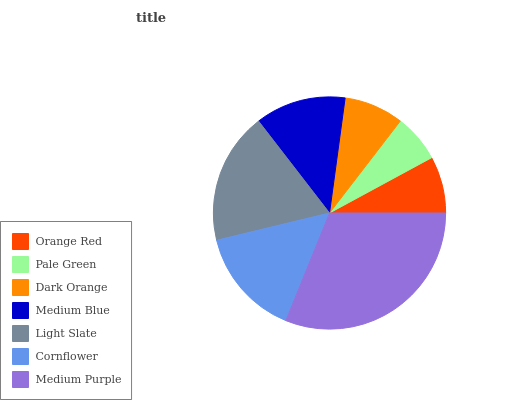Is Pale Green the minimum?
Answer yes or no. Yes. Is Medium Purple the maximum?
Answer yes or no. Yes. Is Dark Orange the minimum?
Answer yes or no. No. Is Dark Orange the maximum?
Answer yes or no. No. Is Dark Orange greater than Pale Green?
Answer yes or no. Yes. Is Pale Green less than Dark Orange?
Answer yes or no. Yes. Is Pale Green greater than Dark Orange?
Answer yes or no. No. Is Dark Orange less than Pale Green?
Answer yes or no. No. Is Medium Blue the high median?
Answer yes or no. Yes. Is Medium Blue the low median?
Answer yes or no. Yes. Is Orange Red the high median?
Answer yes or no. No. Is Medium Purple the low median?
Answer yes or no. No. 